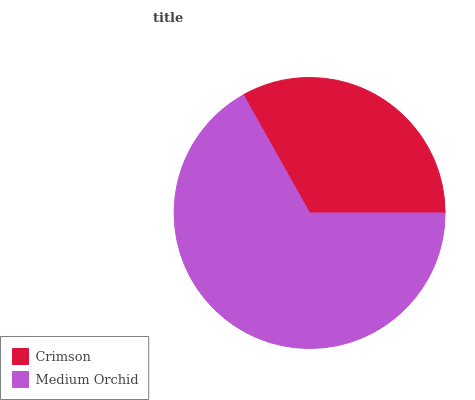Is Crimson the minimum?
Answer yes or no. Yes. Is Medium Orchid the maximum?
Answer yes or no. Yes. Is Medium Orchid the minimum?
Answer yes or no. No. Is Medium Orchid greater than Crimson?
Answer yes or no. Yes. Is Crimson less than Medium Orchid?
Answer yes or no. Yes. Is Crimson greater than Medium Orchid?
Answer yes or no. No. Is Medium Orchid less than Crimson?
Answer yes or no. No. Is Medium Orchid the high median?
Answer yes or no. Yes. Is Crimson the low median?
Answer yes or no. Yes. Is Crimson the high median?
Answer yes or no. No. Is Medium Orchid the low median?
Answer yes or no. No. 